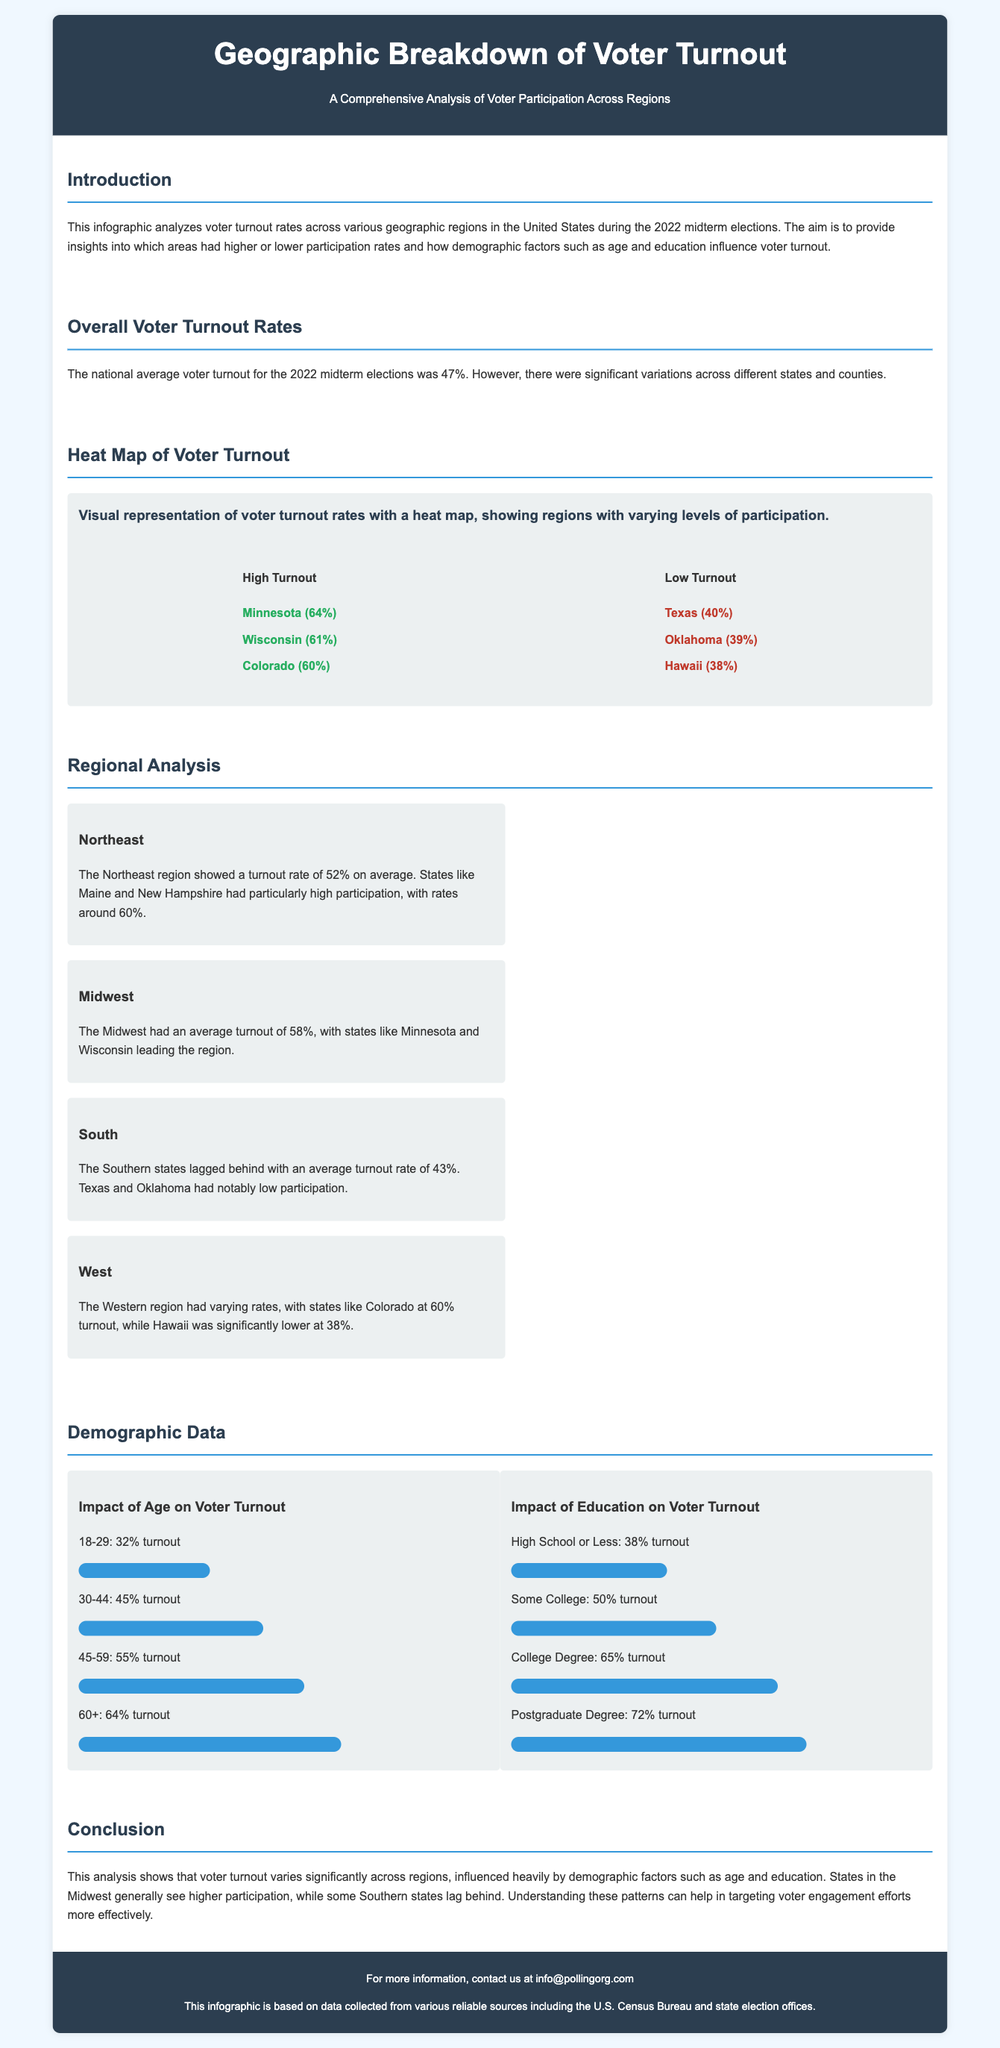What was the national average voter turnout for the 2022 midterm elections? The document states that the national average voter turnout for the 2022 midterm elections was 47%.
Answer: 47% Which state had the highest voter turnout rate? According to the heat map section, Minnesota had the highest voter turnout rate at 64%.
Answer: Minnesota What turnout rate did Texas achieve? The document lists Texas with a turnout rate of 40%.
Answer: 40% How does voter turnout correlate with educational attainment for those with a college degree? The infographic indicates that voters with a college degree had a turnout rate of 65%.
Answer: 65% In which region was voter turnout the lowest? The Southern region is mentioned as having the lowest average turnout rate, with an average of 43%.
Answer: South What percentage of voters aged 18-29 participated in the elections? The document provides that the turnout rate for voters aged 18-29 was 32%.
Answer: 32% Which demographic group had the highest turnout rate based on age? The document shows that the age group 60 and older had the highest turnout rate of 64%.
Answer: 60+ How was the turnout rate for some college education voters? The turnout rate for voters with some college education was reported as 50%.
Answer: 50% What was the average voter turnout rate in the Midwest? The Midwest region had an average turnout rate of 58%.
Answer: 58% 